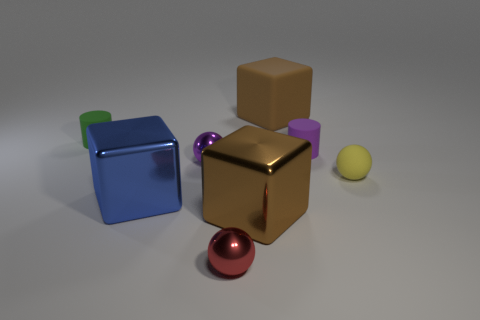Are there an equal number of large blue blocks in front of the big blue object and yellow matte cylinders?
Make the answer very short. Yes. There is a large blue thing that is the same shape as the big brown metallic object; what is its material?
Your answer should be very brief. Metal. There is a object that is to the right of the matte cylinder right of the large blue block; what shape is it?
Give a very brief answer. Sphere. Is the material of the tiny ball that is left of the small red metallic thing the same as the red object?
Your answer should be compact. Yes. Are there an equal number of tiny rubber cylinders that are to the right of the tiny purple sphere and tiny purple rubber cylinders behind the purple cylinder?
Provide a short and direct response. No. There is a matte object that is on the left side of the red shiny thing; how many large things are on the left side of it?
Keep it short and to the point. 0. Does the cube behind the tiny purple rubber object have the same color as the large metal cube that is to the right of the big blue metal block?
Your response must be concise. Yes. What is the material of the red ball that is the same size as the yellow sphere?
Give a very brief answer. Metal. What is the shape of the small rubber object that is to the left of the brown metallic thing that is in front of the big block that is behind the green cylinder?
Make the answer very short. Cylinder. What is the shape of the green rubber object that is the same size as the red metal thing?
Offer a very short reply. Cylinder. 